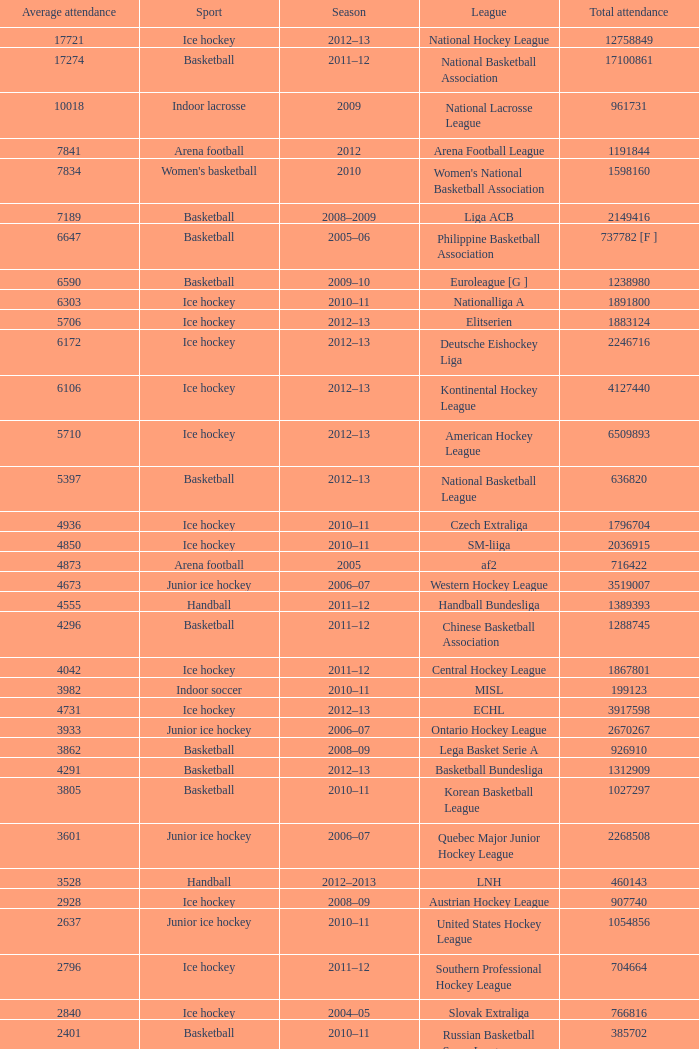Could you parse the entire table as a dict? {'header': ['Average attendance', 'Sport', 'Season', 'League', 'Total attendance'], 'rows': [['17721', 'Ice hockey', '2012–13', 'National Hockey League', '12758849'], ['17274', 'Basketball', '2011–12', 'National Basketball Association', '17100861'], ['10018', 'Indoor lacrosse', '2009', 'National Lacrosse League', '961731'], ['7841', 'Arena football', '2012', 'Arena Football League', '1191844'], ['7834', "Women's basketball", '2010', "Women's National Basketball Association", '1598160'], ['7189', 'Basketball', '2008–2009', 'Liga ACB', '2149416'], ['6647', 'Basketball', '2005–06', 'Philippine Basketball Association', '737782 [F ]'], ['6590', 'Basketball', '2009–10', 'Euroleague [G ]', '1238980'], ['6303', 'Ice hockey', '2010–11', 'Nationalliga A', '1891800'], ['5706', 'Ice hockey', '2012–13', 'Elitserien', '1883124'], ['6172', 'Ice hockey', '2012–13', 'Deutsche Eishockey Liga', '2246716'], ['6106', 'Ice hockey', '2012–13', 'Kontinental Hockey League', '4127440'], ['5710', 'Ice hockey', '2012–13', 'American Hockey League', '6509893'], ['5397', 'Basketball', '2012–13', 'National Basketball League', '636820'], ['4936', 'Ice hockey', '2010–11', 'Czech Extraliga', '1796704'], ['4850', 'Ice hockey', '2010–11', 'SM-liiga', '2036915'], ['4873', 'Arena football', '2005', 'af2', '716422'], ['4673', 'Junior ice hockey', '2006–07', 'Western Hockey League', '3519007'], ['4555', 'Handball', '2011–12', 'Handball Bundesliga', '1389393'], ['4296', 'Basketball', '2011–12', 'Chinese Basketball Association', '1288745'], ['4042', 'Ice hockey', '2011–12', 'Central Hockey League', '1867801'], ['3982', 'Indoor soccer', '2010–11', 'MISL', '199123'], ['4731', 'Ice hockey', '2012–13', 'ECHL', '3917598'], ['3933', 'Junior ice hockey', '2006–07', 'Ontario Hockey League', '2670267'], ['3862', 'Basketball', '2008–09', 'Lega Basket Serie A', '926910'], ['4291', 'Basketball', '2012–13', 'Basketball Bundesliga', '1312909'], ['3805', 'Basketball', '2010–11', 'Korean Basketball League', '1027297'], ['3601', 'Junior ice hockey', '2006–07', 'Quebec Major Junior Hockey League', '2268508'], ['3528', 'Handball', '2012–2013', 'LNH', '460143'], ['2928', 'Ice hockey', '2008–09', 'Austrian Hockey League', '907740'], ['2637', 'Junior ice hockey', '2010–11', 'United States Hockey League', '1054856'], ['2796', 'Ice hockey', '2011–12', 'Southern Professional Hockey League', '704664'], ['2840', 'Ice hockey', '2004–05', 'Slovak Extraliga', '766816'], ['2401', 'Basketball', '2010–11', 'Russian Basketball Super League', '385702'], ['2512', 'Volleyball', '2005–06', 'Lega Pallavolo Serie A', '469799'], ['3227', 'Ice hockey', '2012–13', 'HockeyAllsvenskan', '1174766'], ['2322', 'Ice Hockey', '2009–10', 'Elite Ice Hockey League', '743040'], ['1534', 'Ice hockey', '2007–08', 'Oddset Ligaen', '407972'], ['1335', 'Ice hockey', '2005–06', 'UPC Ligaen', '329768'], ['1269', 'Junior ice hockey', '2010–11', 'North American Hockey League', '957323'], ['1174', 'Volleyball', '2005–06', 'Pro A Volleyball', '213678'], ['632', 'Rink hockey', '2007–08', 'Italian Rink Hockey League', '115000'], ['467', 'Ice Hockey', '2012–13', 'Minor Hockey League', '479003'], ['1932', 'Ice Hockey', '2012–13', 'Major Hockey League', '1356319'], ['2627', 'Basketball', '2012–13', 'VTB United League', '572747'], ['447', "Women's handball", '2005–06', 'Norwegian Premier League', '58958'], ['1940', 'Basketball', '2011–12', 'Polska Liga Koszykówki', '535559']]} What's the average attendance of the league with a total attendance of 2268508? 3601.0. 